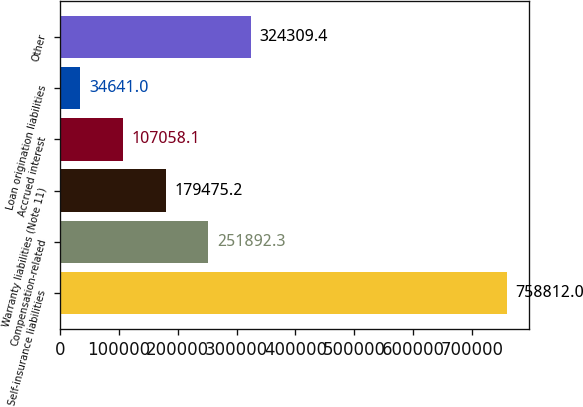Convert chart. <chart><loc_0><loc_0><loc_500><loc_500><bar_chart><fcel>Self-insurance liabilities<fcel>Compensation-related<fcel>Warranty liabilities (Note 11)<fcel>Accrued interest<fcel>Loan origination liabilities<fcel>Other<nl><fcel>758812<fcel>251892<fcel>179475<fcel>107058<fcel>34641<fcel>324309<nl></chart> 